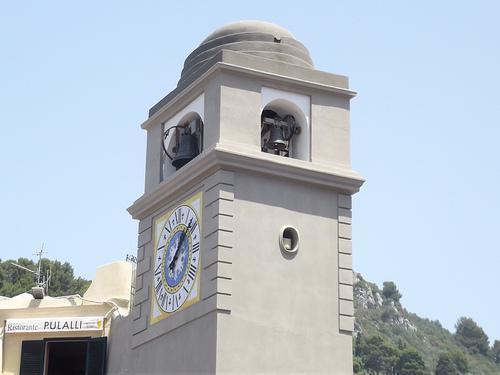How many clocks are shown?
Give a very brief answer. 1. How many bells are shown?
Give a very brief answer. 2. 